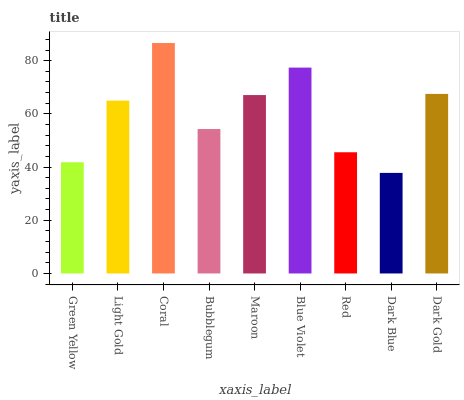Is Dark Blue the minimum?
Answer yes or no. Yes. Is Coral the maximum?
Answer yes or no. Yes. Is Light Gold the minimum?
Answer yes or no. No. Is Light Gold the maximum?
Answer yes or no. No. Is Light Gold greater than Green Yellow?
Answer yes or no. Yes. Is Green Yellow less than Light Gold?
Answer yes or no. Yes. Is Green Yellow greater than Light Gold?
Answer yes or no. No. Is Light Gold less than Green Yellow?
Answer yes or no. No. Is Light Gold the high median?
Answer yes or no. Yes. Is Light Gold the low median?
Answer yes or no. Yes. Is Green Yellow the high median?
Answer yes or no. No. Is Green Yellow the low median?
Answer yes or no. No. 